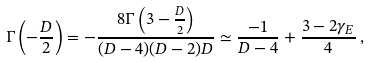<formula> <loc_0><loc_0><loc_500><loc_500>\Gamma \left ( - \frac { D } { 2 } \right ) = - \frac { 8 \Gamma \left ( 3 - \frac { D } { 2 } \right ) } { ( D - 4 ) ( D - 2 ) D } \simeq \frac { - 1 } { D - 4 } + \frac { 3 - 2 \gamma _ { E } } { 4 } \, ,</formula> 